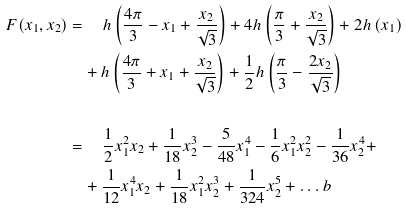<formula> <loc_0><loc_0><loc_500><loc_500>F ( x _ { 1 } , x _ { 2 } ) = & \quad \, h \left ( \frac { 4 \pi } { 3 } - x _ { 1 } + \frac { x _ { 2 } } { \sqrt { 3 } } \right ) + 4 h \left ( \frac { \pi } { 3 } + \frac { x _ { 2 } } { \sqrt { 3 } } \right ) + 2 h \left ( x _ { 1 } \right ) \\ & + h \left ( \frac { 4 \pi } { 3 } + x _ { 1 } + \frac { x _ { 2 } } { \sqrt { 3 } } \right ) + \frac { 1 } { 2 } h \left ( \frac { \pi } { 3 } - \frac { 2 x _ { 2 } } { \sqrt { 3 } } \right ) \\ & \quad \\ = & \quad \, \frac { 1 } { 2 } x _ { 1 } ^ { 2 } x _ { 2 } + \frac { 1 } { 1 8 } x _ { 2 } ^ { 3 } - \frac { 5 } { 4 8 } x _ { 1 } ^ { 4 } - \frac { 1 } { 6 } x _ { 1 } ^ { 2 } x _ { 2 } ^ { 2 } - \frac { 1 } { 3 6 } x _ { 2 } ^ { 4 } + \\ & + \frac { 1 } { 1 2 } x _ { 1 } ^ { 4 } x _ { 2 } + \frac { 1 } { 1 8 } x _ { 1 } ^ { 2 } x _ { 2 } ^ { 3 } + \frac { 1 } { 3 2 4 } x _ { 2 } ^ { 5 } + \dots b</formula> 